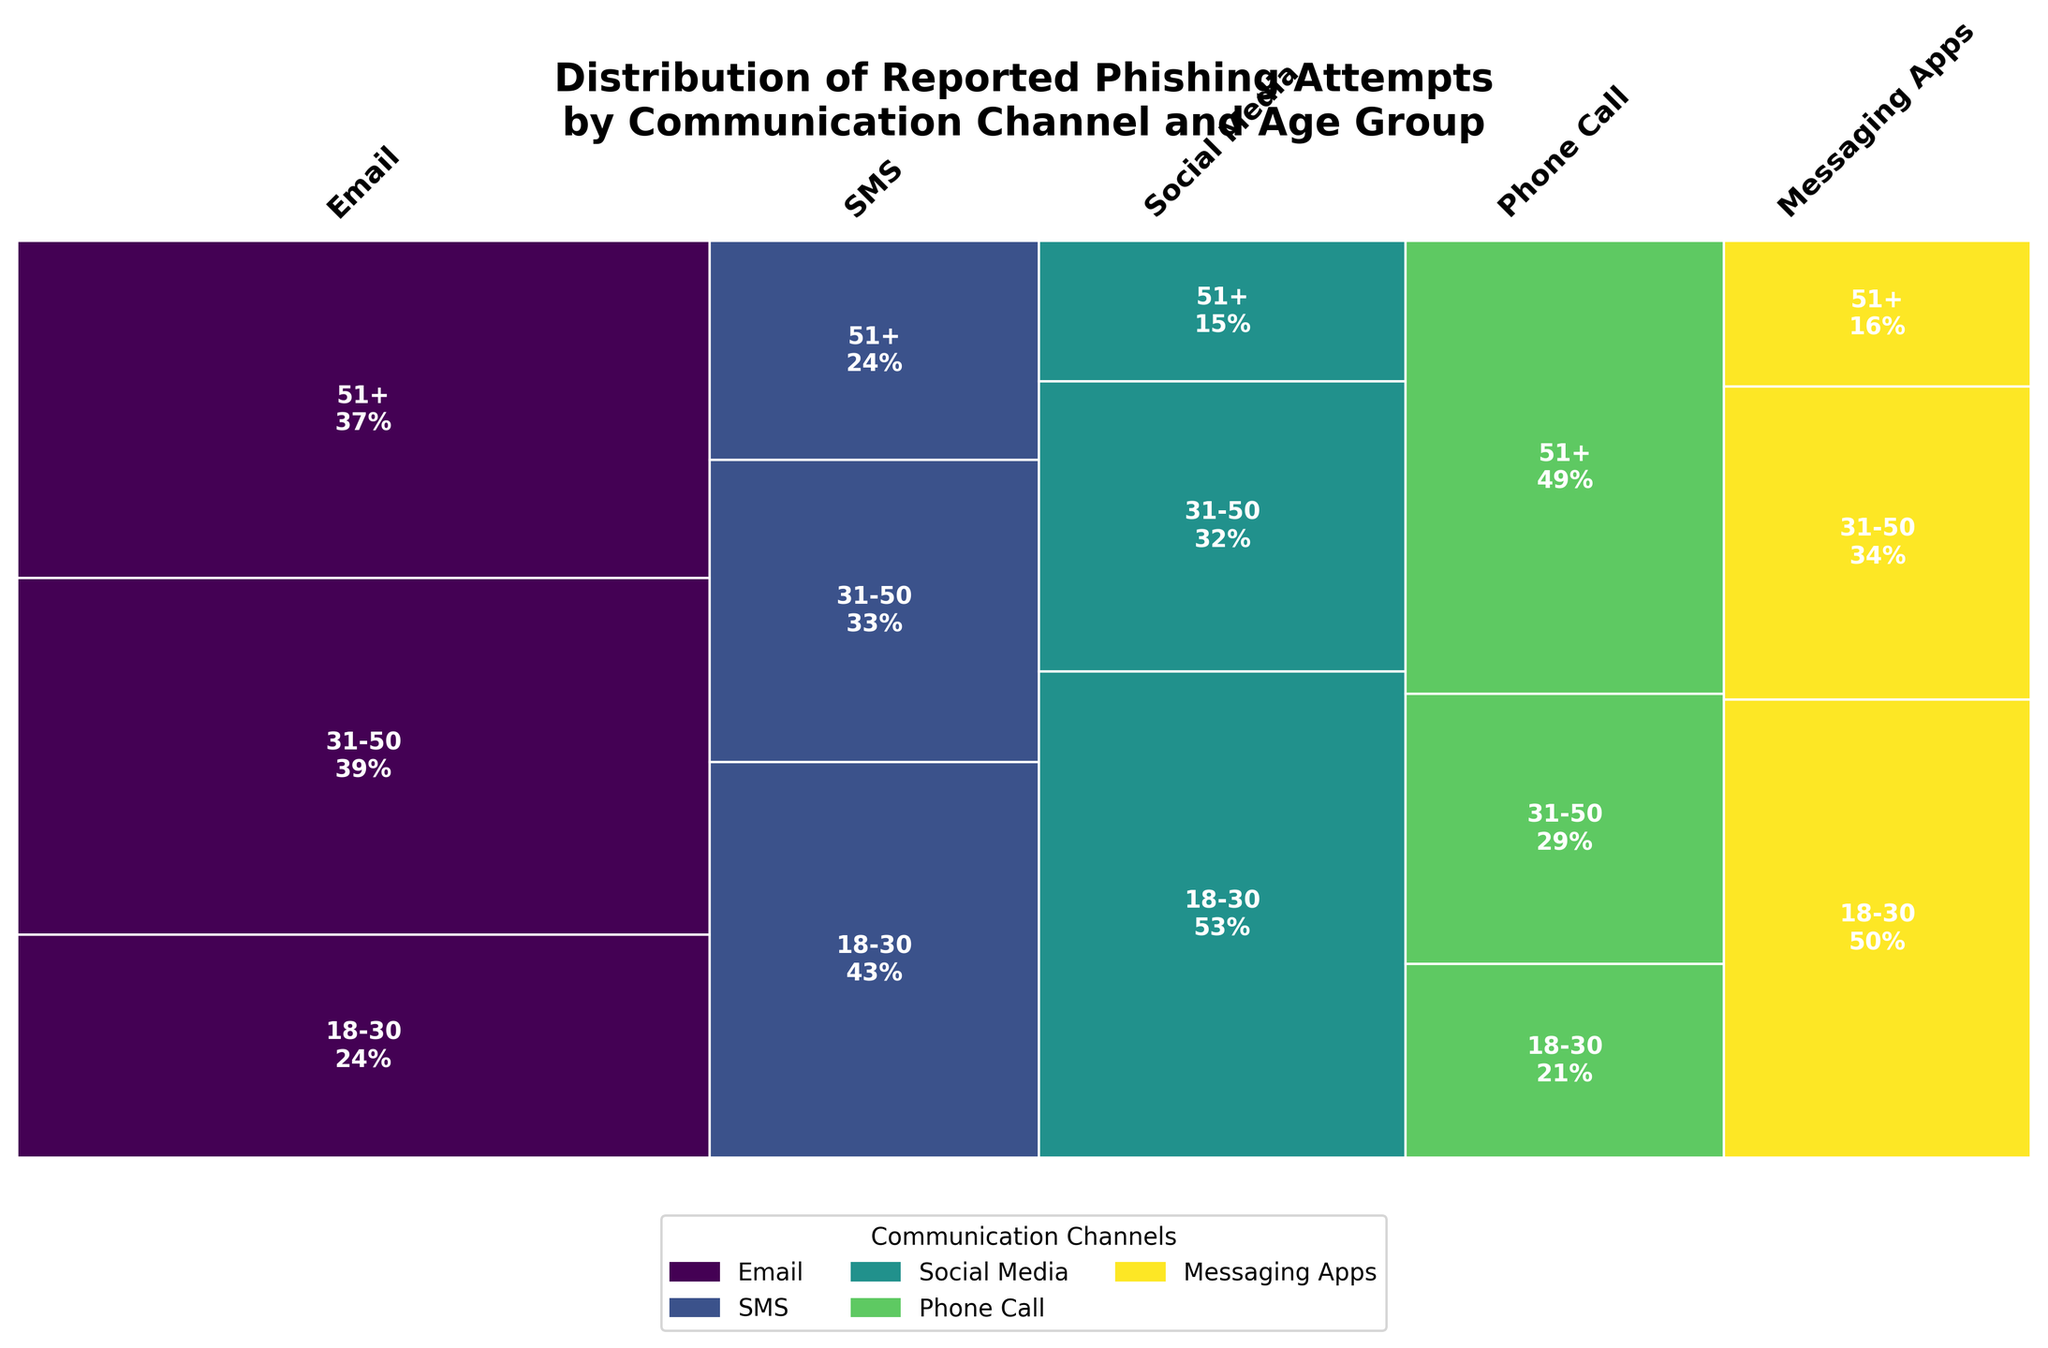What is the title of the plot? The title of the plot is written at the top and reads "Distribution of Reported Phishing Attempts by Communication Channel and Age Group"
Answer: Distribution of Reported Phishing Attempts by Communication Channel and Age Group Which communication channel has the highest proportion of reported phishing attempts? The plot shows various communication channels with different widths representing proportions. The widest bar represents the channel with the highest proportion.
Answer: Email Which age group has the highest proportion of reported phishing attempts within the Social Media channel? For Social Media, look at the three segments within this channel and compare their heights. The tallest segment represents the age group with the highest proportion.
Answer: 18-30 How does the proportion of phishing attempts reported via SMS compare between the 18-30 and 51+ age groups? For the SMS channel, compare the heights of the segments for the 18-30 and 51+ age groups. The 18-30 age group's segment is taller than the 51+ age group.
Answer: 18-30 is greater than 51+ What is the total proportion of reported phishing attempts for the 31-50 age group across all communication channels? Sum the individual proportions of the 31-50 age group segments within each communication channel based on their heights.
Answer: ~0.28 Identify the communication channel with the lowest overall phishing reports. The narrowest bar in the plot represents the channel with the lowest reported phishing attempts.
Answer: Messaging Apps Which age group shows the least vulnerability to phishing attempts across all communication channels? By observing the heights of the segments across all channels, the age group with the shortest segments overall is the least vulnerable.
Answer: 51+ Compare the phishing reports for the 18-30 age group between Email and Phone Call channels. Which is higher? Within the Email and Phone Call channels, compare the heights of the segments for the 18-30 age group. The segment under Email is taller.
Answer: Email Which communication channel shows a notably uniform distribution of phishing attempts across all age groups? Uniform distribution means equal heights across segments within a channel. The channel with segments of similar height across all age groups is what we are looking for.
Answer: Phone Call 